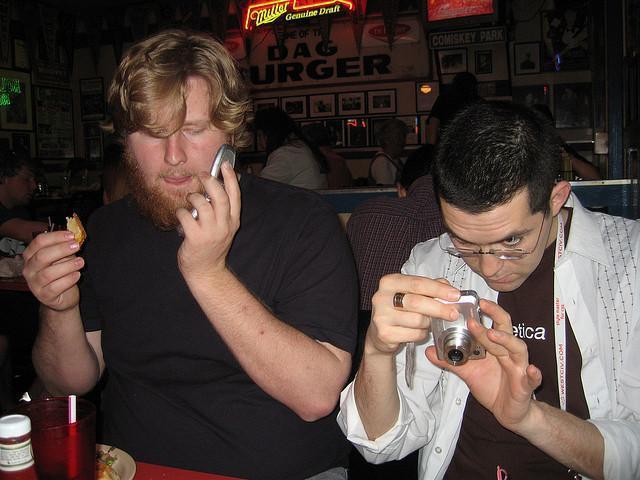How many people can be seen?
Give a very brief answer. 4. How many round donuts have nuts on them in the image?
Give a very brief answer. 0. 